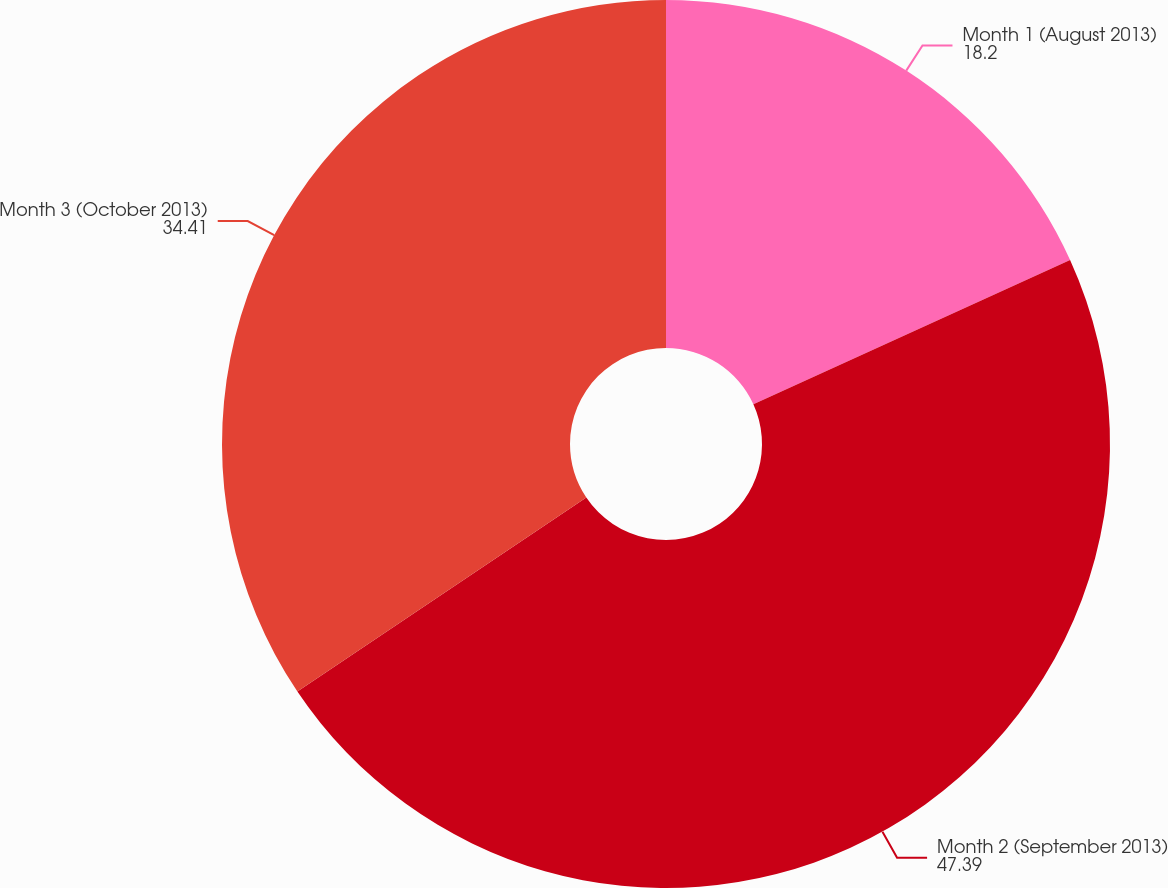Convert chart to OTSL. <chart><loc_0><loc_0><loc_500><loc_500><pie_chart><fcel>Month 1 (August 2013)<fcel>Month 2 (September 2013)<fcel>Month 3 (October 2013)<nl><fcel>18.2%<fcel>47.39%<fcel>34.41%<nl></chart> 